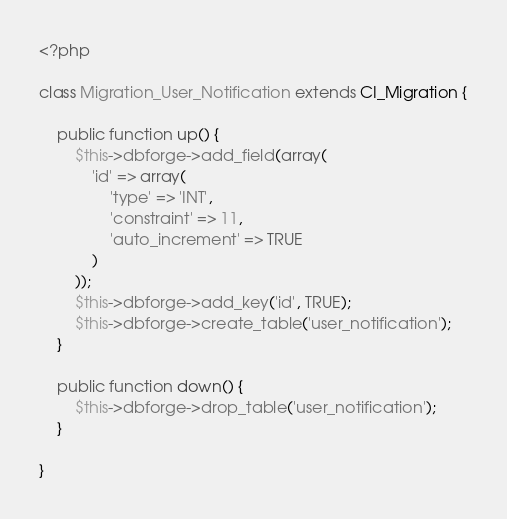Convert code to text. <code><loc_0><loc_0><loc_500><loc_500><_PHP_><?php

class Migration_User_Notification extends CI_Migration {

    public function up() {
        $this->dbforge->add_field(array(
            'id' => array(
                'type' => 'INT',
                'constraint' => 11,
                'auto_increment' => TRUE
            )
        ));
        $this->dbforge->add_key('id', TRUE);
        $this->dbforge->create_table('user_notification');
    }

    public function down() {
        $this->dbforge->drop_table('user_notification');
    }

}</code> 